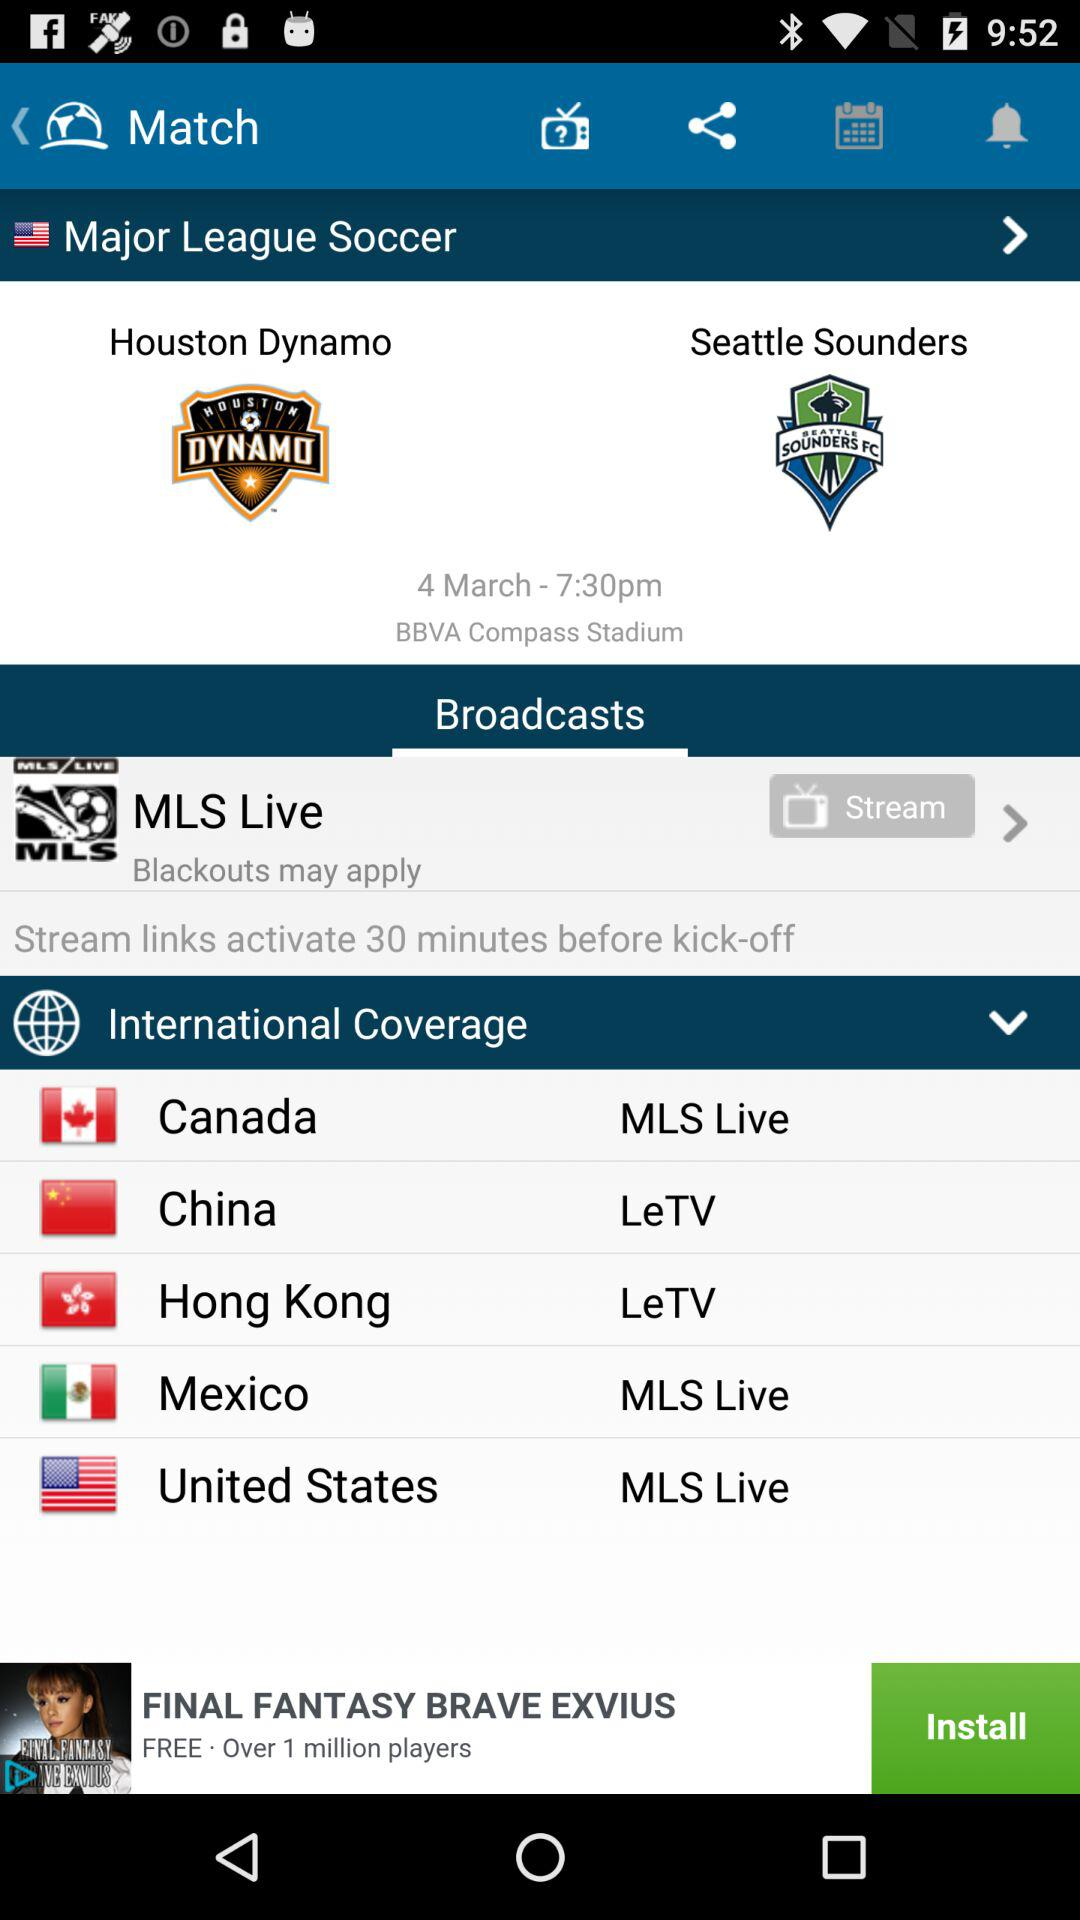How much time before kickoff will the stream links activate? The stream links activate 30 minutes before kickoff. 